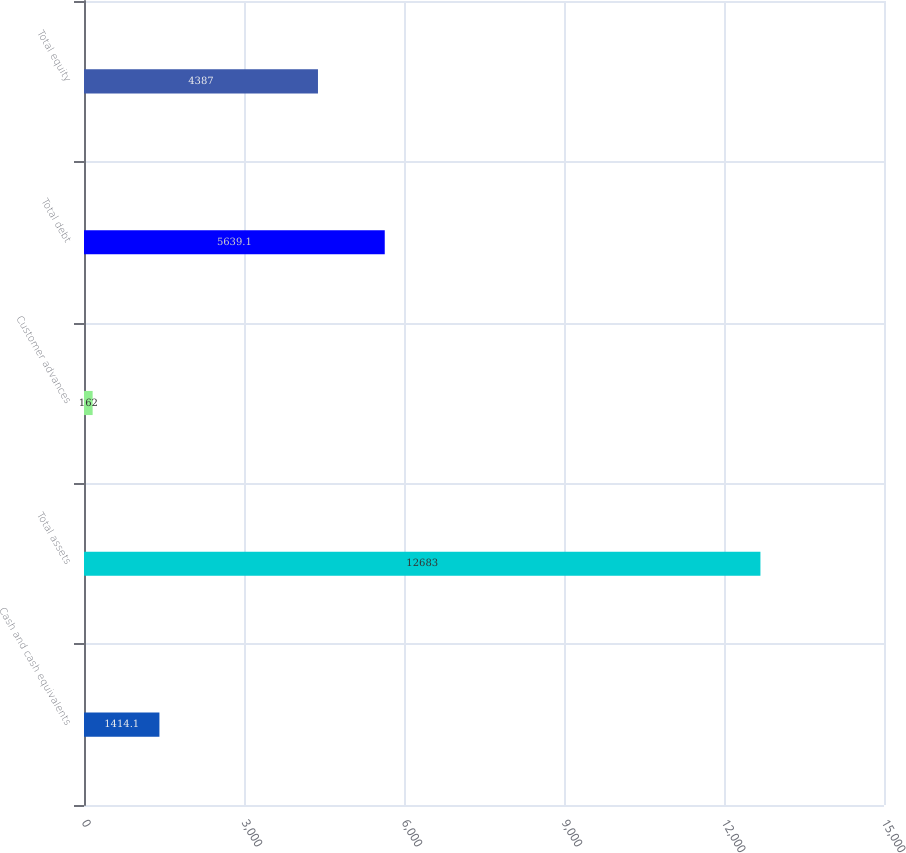Convert chart to OTSL. <chart><loc_0><loc_0><loc_500><loc_500><bar_chart><fcel>Cash and cash equivalents<fcel>Total assets<fcel>Customer advances<fcel>Total debt<fcel>Total equity<nl><fcel>1414.1<fcel>12683<fcel>162<fcel>5639.1<fcel>4387<nl></chart> 